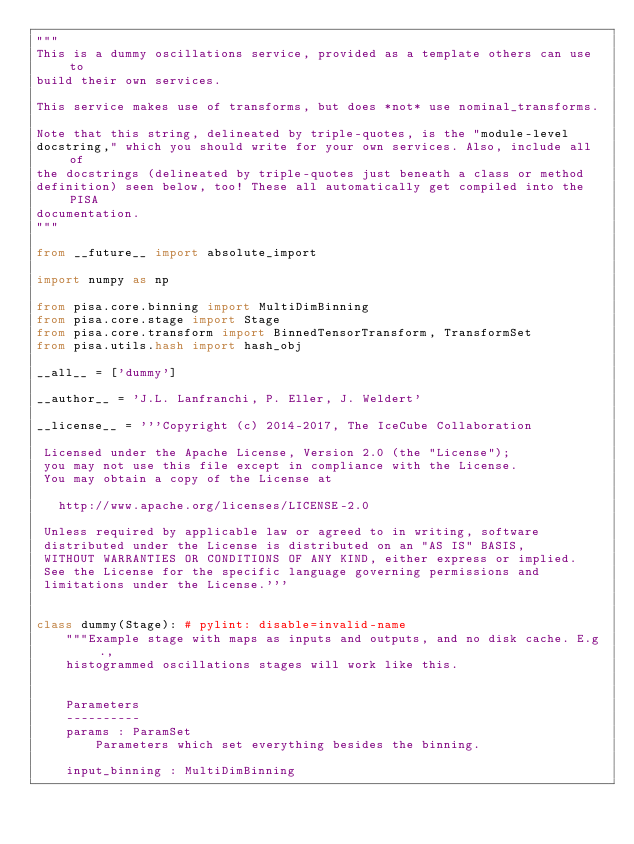Convert code to text. <code><loc_0><loc_0><loc_500><loc_500><_Python_>"""
This is a dummy oscillations service, provided as a template others can use to
build their own services.

This service makes use of transforms, but does *not* use nominal_transforms.

Note that this string, delineated by triple-quotes, is the "module-level
docstring," which you should write for your own services. Also, include all of
the docstrings (delineated by triple-quotes just beneath a class or method
definition) seen below, too! These all automatically get compiled into the PISA
documentation.
"""

from __future__ import absolute_import

import numpy as np

from pisa.core.binning import MultiDimBinning
from pisa.core.stage import Stage
from pisa.core.transform import BinnedTensorTransform, TransformSet
from pisa.utils.hash import hash_obj

__all__ = ['dummy']

__author__ = 'J.L. Lanfranchi, P. Eller, J. Weldert'

__license__ = '''Copyright (c) 2014-2017, The IceCube Collaboration

 Licensed under the Apache License, Version 2.0 (the "License");
 you may not use this file except in compliance with the License.
 You may obtain a copy of the License at

   http://www.apache.org/licenses/LICENSE-2.0

 Unless required by applicable law or agreed to in writing, software
 distributed under the License is distributed on an "AS IS" BASIS,
 WITHOUT WARRANTIES OR CONDITIONS OF ANY KIND, either express or implied.
 See the License for the specific language governing permissions and
 limitations under the License.'''


class dummy(Stage): # pylint: disable=invalid-name
    """Example stage with maps as inputs and outputs, and no disk cache. E.g.,
    histogrammed oscillations stages will work like this.


    Parameters
    ----------
    params : ParamSet
        Parameters which set everything besides the binning.

    input_binning : MultiDimBinning</code> 